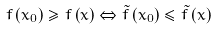<formula> <loc_0><loc_0><loc_500><loc_500>f \left ( x _ { 0 } \right ) \geq f \left ( x \right ) \Leftrightarrow { \tilde { f } } \left ( x _ { 0 } \right ) \leq { \tilde { f } } \left ( x \right )</formula> 